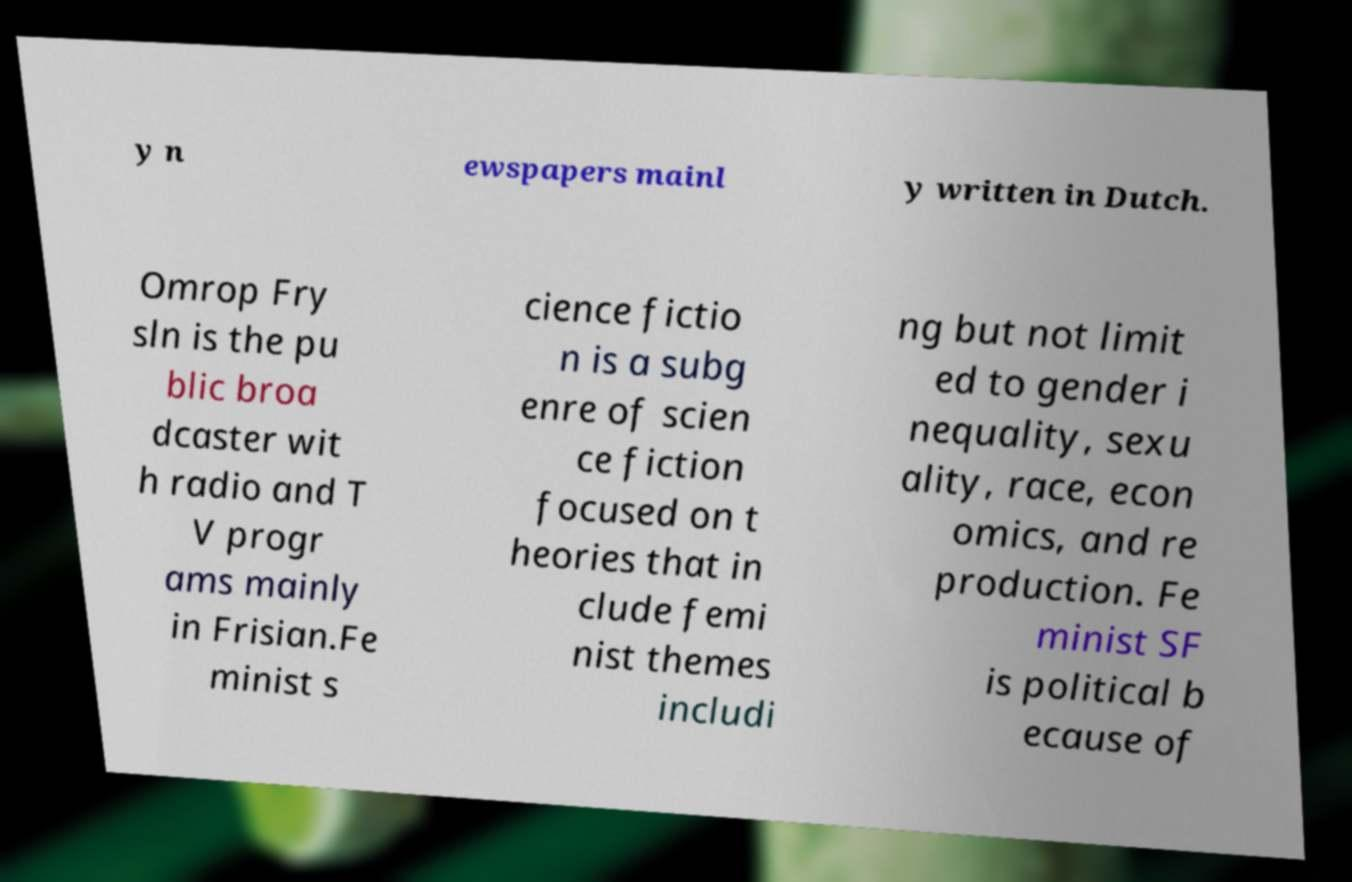There's text embedded in this image that I need extracted. Can you transcribe it verbatim? y n ewspapers mainl y written in Dutch. Omrop Fry sln is the pu blic broa dcaster wit h radio and T V progr ams mainly in Frisian.Fe minist s cience fictio n is a subg enre of scien ce fiction focused on t heories that in clude femi nist themes includi ng but not limit ed to gender i nequality, sexu ality, race, econ omics, and re production. Fe minist SF is political b ecause of 